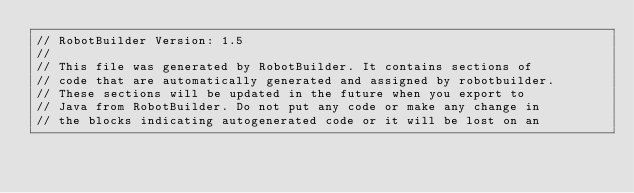Convert code to text. <code><loc_0><loc_0><loc_500><loc_500><_Java_>// RobotBuilder Version: 1.5
//
// This file was generated by RobotBuilder. It contains sections of
// code that are automatically generated and assigned by robotbuilder.
// These sections will be updated in the future when you export to
// Java from RobotBuilder. Do not put any code or make any change in
// the blocks indicating autogenerated code or it will be lost on an</code> 